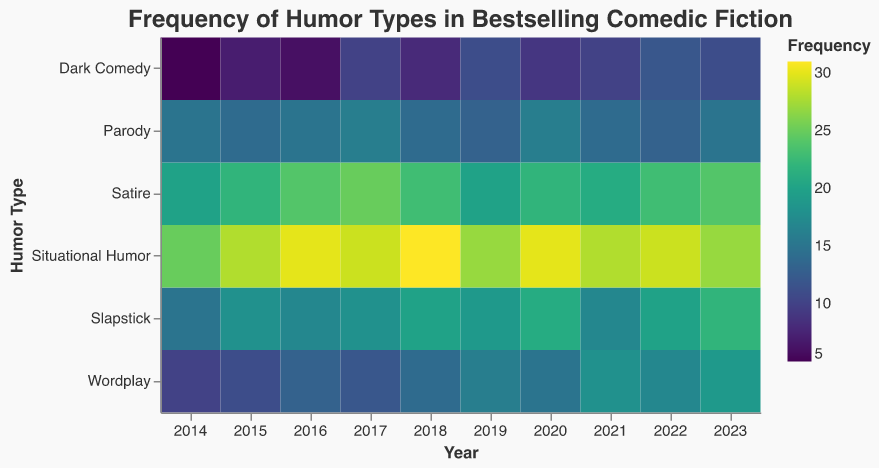What is the title of the heatmap? The title of the heatmap is displayed at the top, usually in larger or bold text. In this figure, the title is "Frequency of Humor Types in Bestselling Comedic Fiction".
Answer: Frequency of Humor Types in Bestselling Comedic Fiction Which year had the highest frequency of Slapstick? To find this, look at the color intensity for the Slapstick row across all years and identify the year with the highest intensity (darkest color). For Slapstick, the year 2023 has the highest frequency with a value of 22.
Answer: 2023 How has the frequency of Dark Comedy changed from 2014 to 2023? Compare the frequency values of Dark Comedy for the years 2014 and 2023. In 2014, the frequency was 5, and in 2023, it increased to 11. This shows an increase in the use of Dark Comedy over the decade.
Answer: Increased from 5 to 11 Calculate the average frequency of Wordplay across all years. Sum the frequency values of Wordplay from 2014 to 2023 and divide by the number of years (10). The values are 10, 11, 13, 12, 14, 16, 15, 18, 17, and 19. Sum: 145, Average: 145/10 = 14.5
Answer: 14.5 Which humor type showed the least variation in frequency over the years? To determine this, review each humor type's frequency across the years and look for the most consistent (least fluctuating) values. Situational Humor remains relatively stable with slight variations between 25 and 31.
Answer: Situational Humor How does the frequency of Parody in 2014 compare to its frequency in 2023? Look at the frequencies for Parody in both years. In 2014, the frequency was 15, and in 2023, it was 15, indicating no change.
Answer: No change, both are 15 What is the trend in the frequency of Satire from 2014 to 2023? Observe the frequency values for Satire for each year from 2014 to 2023. The values are 20, 22, 24, 25, 23, 20, 22, 21, 23, and 24, showing an overall increasing trend with minor fluctuations.
Answer: Increasing trend Identify the year where Wordplay had the highest jump in frequency compared to the previous year. Examine the differences in Wordplay frequency values year over year. The largest jump occurs between 2020 (15) and 2021 (18), which is a jump of 3.
Answer: Between 2020 and 2021 Which humor type had the lowest frequency in any single year, and what was that frequency? Review the frequency values for each humor type across all years and find the minimum value. Dark Comedy in 2014 had the lowest frequency with a value of 5.
Answer: Dark Comedy, 5 